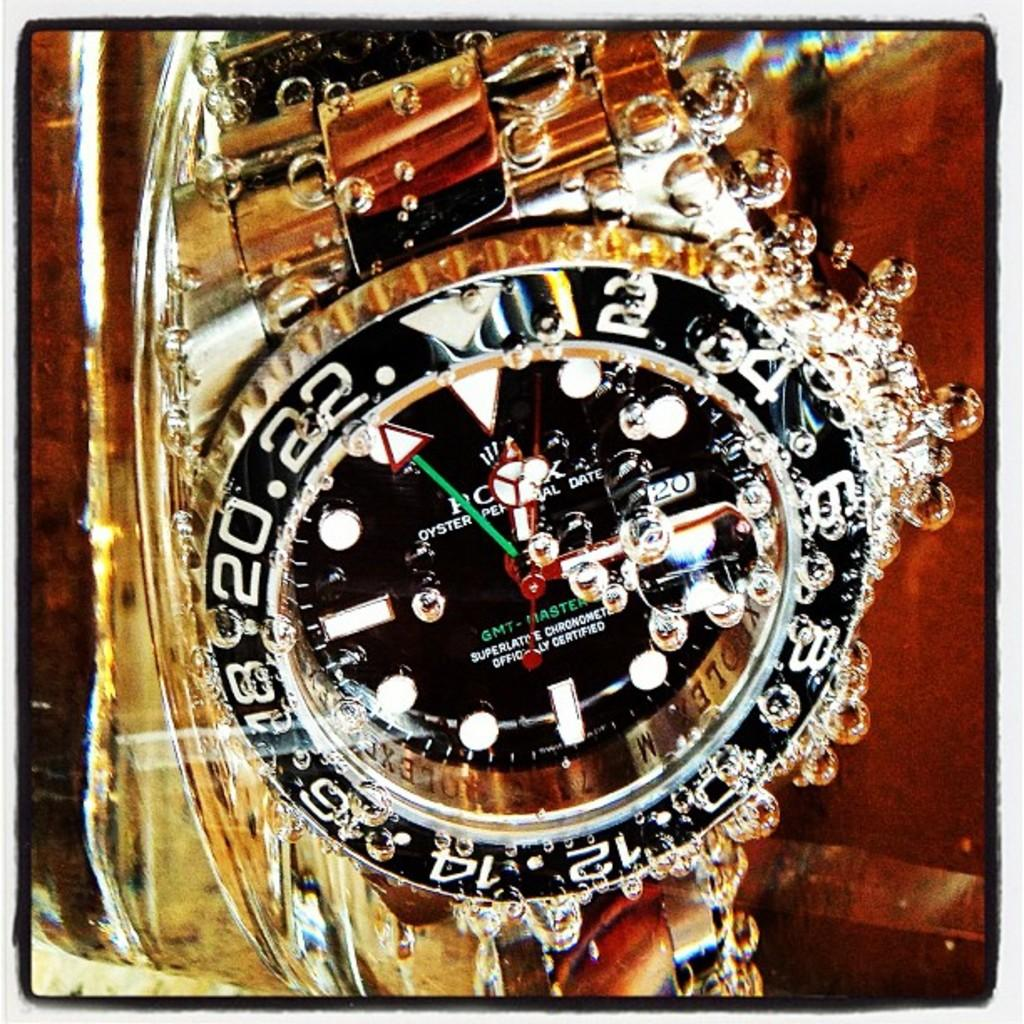<image>
Create a compact narrative representing the image presented. Black and gold watch that says the brand ROLEX on the face. 